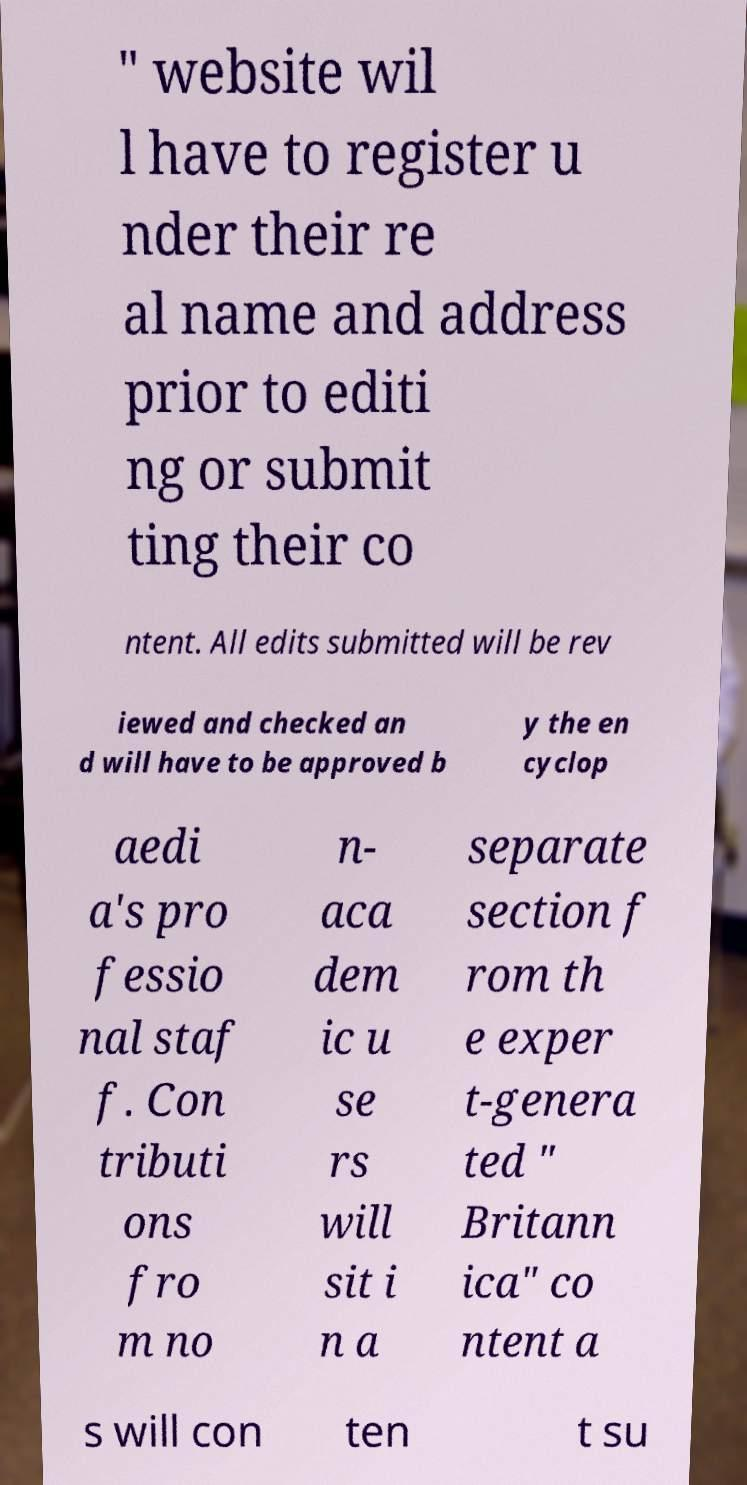Can you accurately transcribe the text from the provided image for me? " website wil l have to register u nder their re al name and address prior to editi ng or submit ting their co ntent. All edits submitted will be rev iewed and checked an d will have to be approved b y the en cyclop aedi a's pro fessio nal staf f. Con tributi ons fro m no n- aca dem ic u se rs will sit i n a separate section f rom th e exper t-genera ted " Britann ica" co ntent a s will con ten t su 